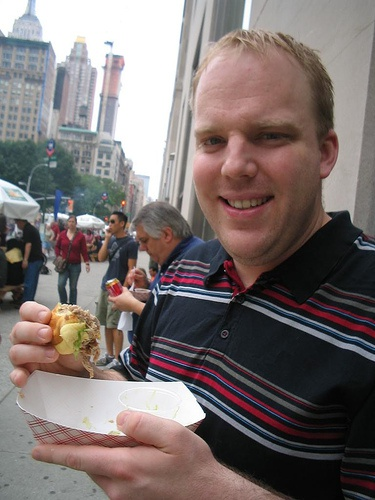Describe the objects in this image and their specific colors. I can see people in white, black, gray, and maroon tones, bowl in white, lightgray, darkgray, gray, and brown tones, people in white, gray, brown, and maroon tones, people in white, black, gray, and maroon tones, and sandwich in white, tan, gray, and olive tones in this image. 